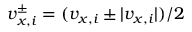<formula> <loc_0><loc_0><loc_500><loc_500>v _ { x , i } ^ { \pm } = ( v _ { x , i } \pm | v _ { x , i } | ) / 2</formula> 